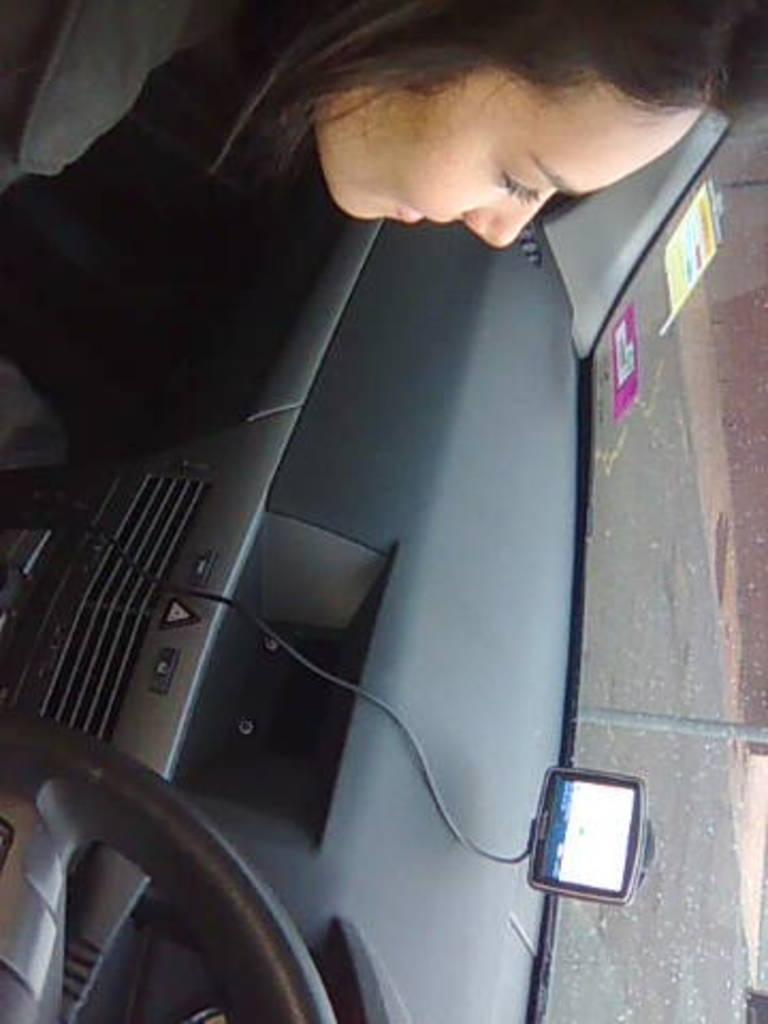Who is present in the image? There is a woman in the image. What is the woman doing in the image? The woman is sitting in a car. What type of sugar is being used for the business transaction in the image? There is no sugar or business transaction present in the image; it only features a woman sitting in a car. 